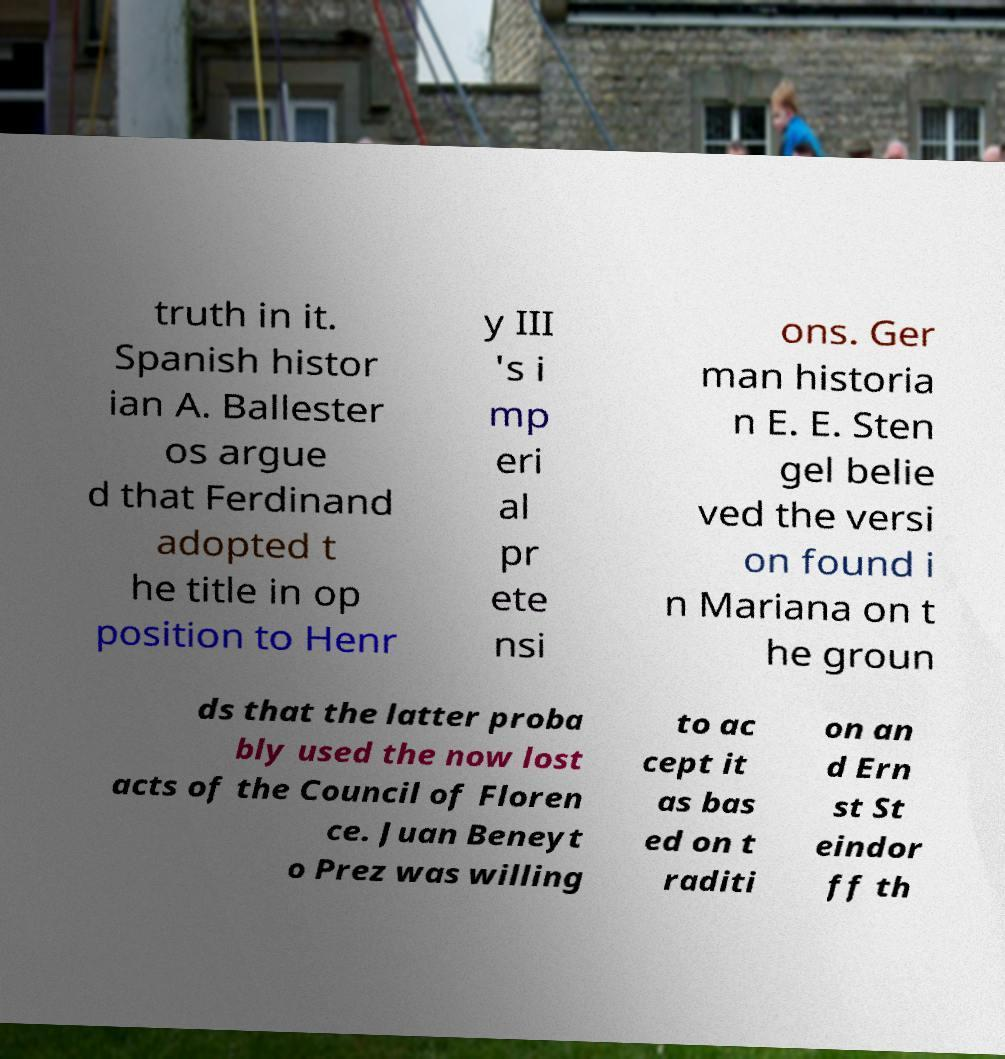Could you assist in decoding the text presented in this image and type it out clearly? truth in it. Spanish histor ian A. Ballester os argue d that Ferdinand adopted t he title in op position to Henr y III 's i mp eri al pr ete nsi ons. Ger man historia n E. E. Sten gel belie ved the versi on found i n Mariana on t he groun ds that the latter proba bly used the now lost acts of the Council of Floren ce. Juan Beneyt o Prez was willing to ac cept it as bas ed on t raditi on an d Ern st St eindor ff th 